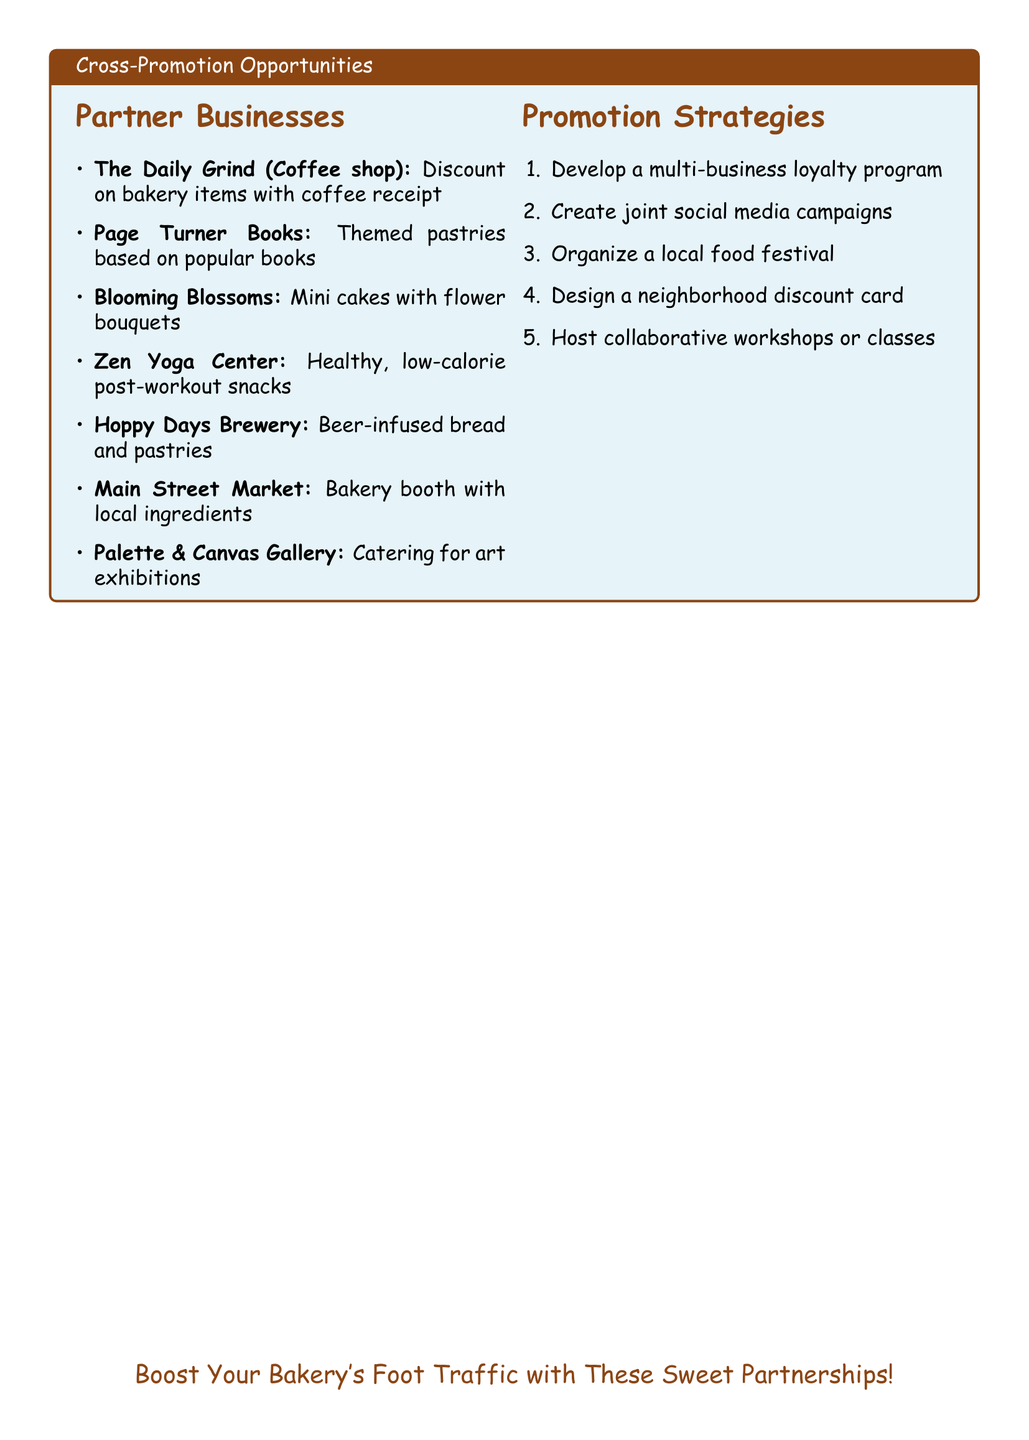what is one business type mentioned for cross-promotion? The document lists various business types, including coffee shops, bookstores, and more for cross-promotion.
Answer: Coffee shop who offers a discount on bakery items? The document specifies that The Daily Grind offers a discount on bakery items.
Answer: The Daily Grind what type of pastries does Zen Yoga Center provide? This business promotes healthy, low-calorie pastries specifically for post-workout snacks.
Answer: Healthy, low-calorie pastries name one promotion strategy listed in the document. The document states multiple strategies, such as developing a loyalty program, to attract clients.
Answer: Develop a loyalty program how many businesses are listed under partner businesses? The document enumerates seven different partner businesses available for cross-promotion.
Answer: Seven which local business is associated with beer-infused products? The document indicates that Hoppy Days Brewery collaborates on creating beer-infused bread and pastries.
Answer: Hoppy Days Brewery what is a unique feature of the collaboration with Palette & Canvas Gallery? The document mentions that they provide catering for art exhibition openings while showcasing bakery items.
Answer: Catering for art exhibitions what type of event does the document suggest organizing to promote local businesses? The document mentions organizing a local food festival as a means of collaboration among businesses.
Answer: Local food festival 